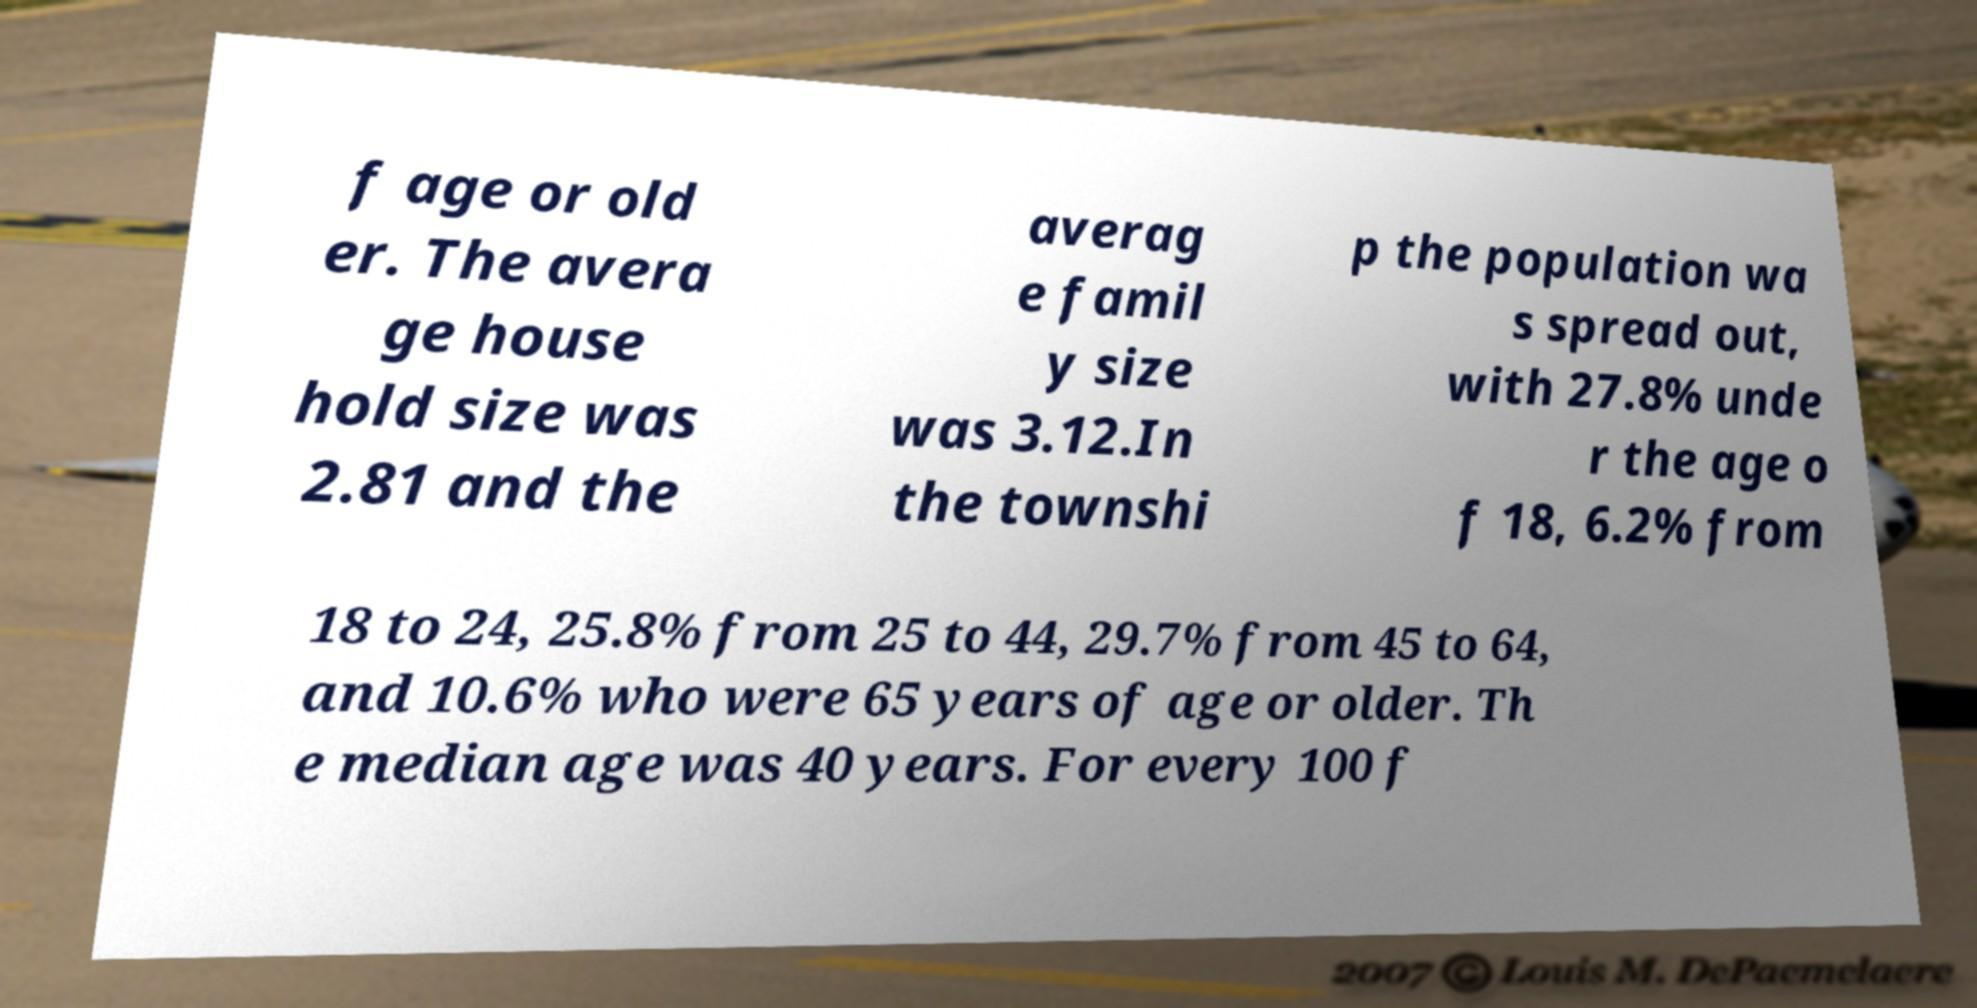Can you accurately transcribe the text from the provided image for me? f age or old er. The avera ge house hold size was 2.81 and the averag e famil y size was 3.12.In the townshi p the population wa s spread out, with 27.8% unde r the age o f 18, 6.2% from 18 to 24, 25.8% from 25 to 44, 29.7% from 45 to 64, and 10.6% who were 65 years of age or older. Th e median age was 40 years. For every 100 f 